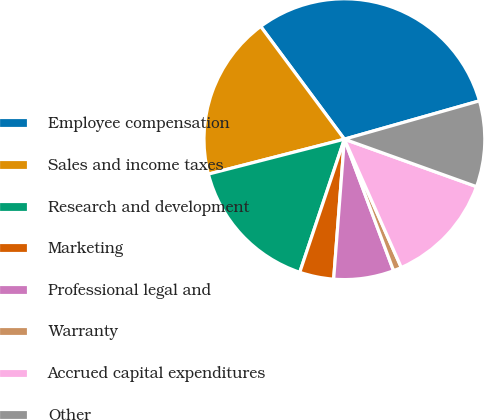<chart> <loc_0><loc_0><loc_500><loc_500><pie_chart><fcel>Employee compensation<fcel>Sales and income taxes<fcel>Research and development<fcel>Marketing<fcel>Professional legal and<fcel>Warranty<fcel>Accrued capital expenditures<fcel>Other<nl><fcel>30.76%<fcel>18.84%<fcel>15.85%<fcel>3.93%<fcel>6.91%<fcel>0.95%<fcel>12.87%<fcel>9.89%<nl></chart> 